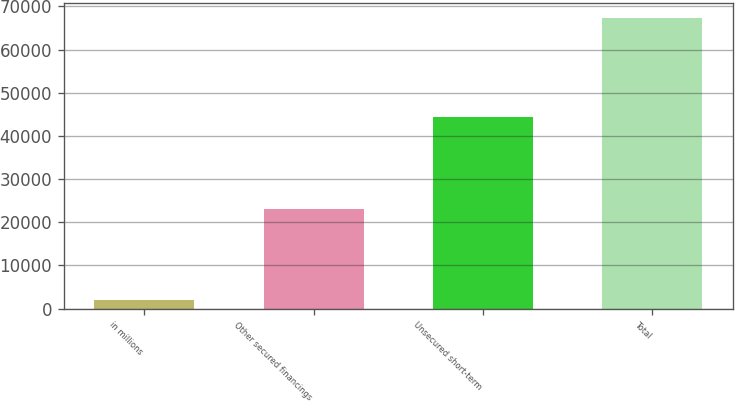Convert chart to OTSL. <chart><loc_0><loc_0><loc_500><loc_500><bar_chart><fcel>in millions<fcel>Other secured financings<fcel>Unsecured short-term<fcel>Total<nl><fcel>2012<fcel>23045<fcel>44304<fcel>67349<nl></chart> 